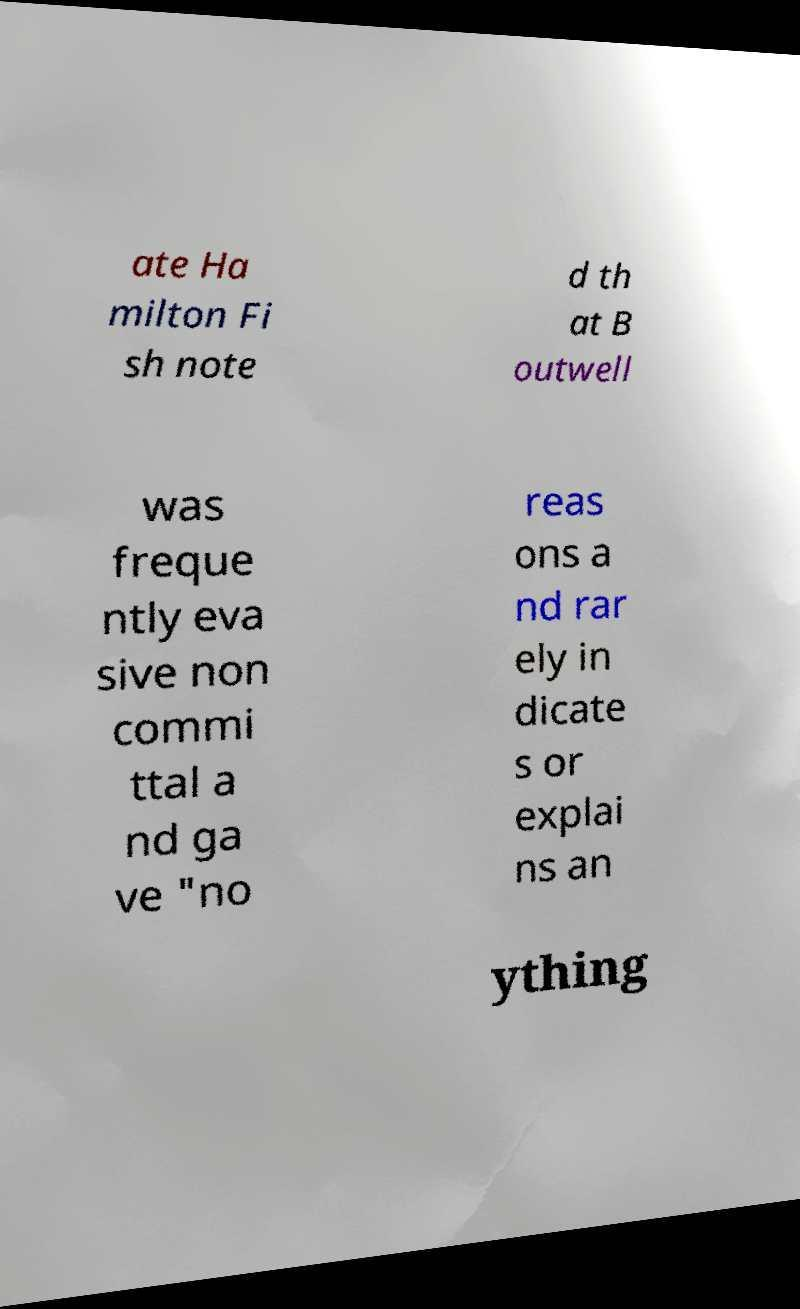Please read and relay the text visible in this image. What does it say? ate Ha milton Fi sh note d th at B outwell was freque ntly eva sive non commi ttal a nd ga ve "no reas ons a nd rar ely in dicate s or explai ns an ything 